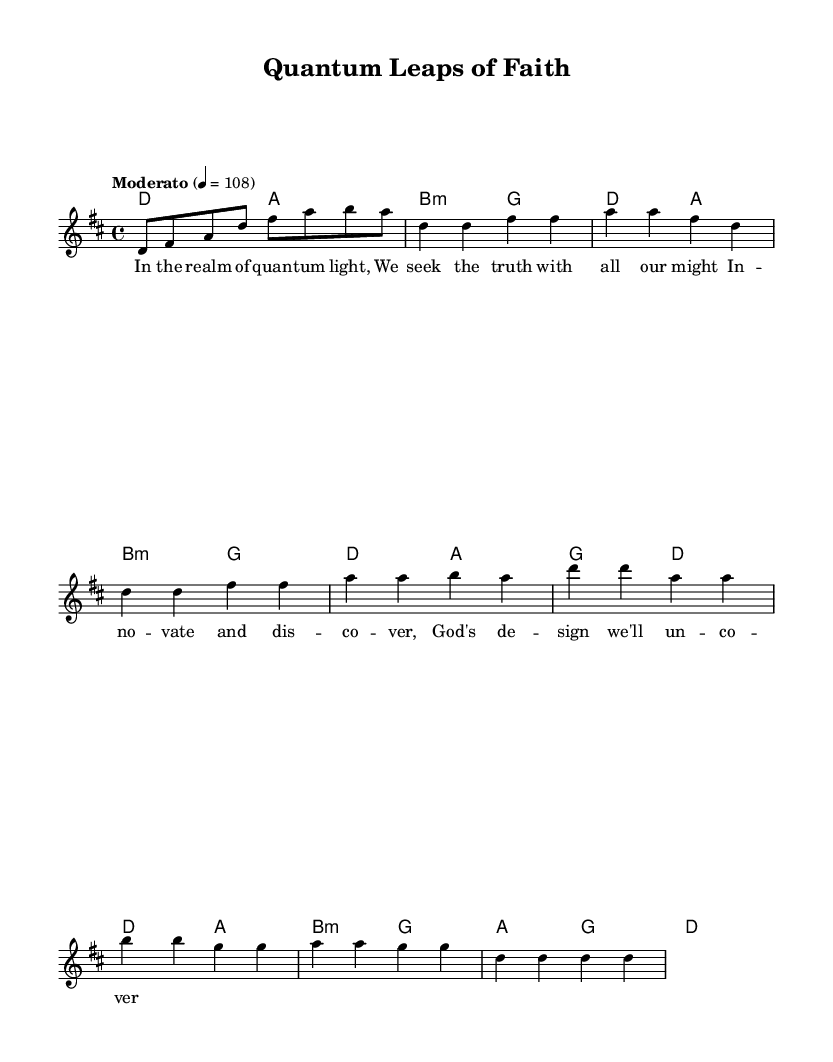What is the key signature of this music? The sheet music is in the key of D major, indicated by the two sharps (F# and C#) in the key signature at the beginning of the staff.
Answer: D major What is the time signature of this music? The time signature shown at the beginning is 4/4, which means there are four beats in each measure, and the quarter note gets one beat.
Answer: 4/4 What is the tempo marking for this piece? The tempo is marked as "Moderato" with a metronome marking of quarter note = 108, indicating a moderate pace for the performance.
Answer: Moderato How many measures are in the chorus section? By counting the measures in the chorus section of the music, there are a total of four measures indicated by the notes and bar lines.
Answer: 4 What is the main theme expressed in the chorus lyrics? The main theme of the chorus revolves around innovation and uncovering God's design, as suggested by the lyrics. This indicates a relationship between faith and the exploration of new ideas.
Answer: Innovation Which section contains the phrase "We seek the truth with all our might"? This phrase is the first line of Verse 1, clearly shown in the lyrics section corresponding to the melody part.
Answer: Verse 1 What musical form does this piece primarily follow? The piece primarily follows a verse-chorus form, which is common in contemporary Christian rock. The structure alternates between verse sections and a repeating chorus.
Answer: Verse-chorus form 